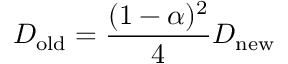Convert formula to latex. <formula><loc_0><loc_0><loc_500><loc_500>D _ { o l d } = \frac { ( 1 - \alpha ) ^ { 2 } } { 4 } D _ { n e w }</formula> 